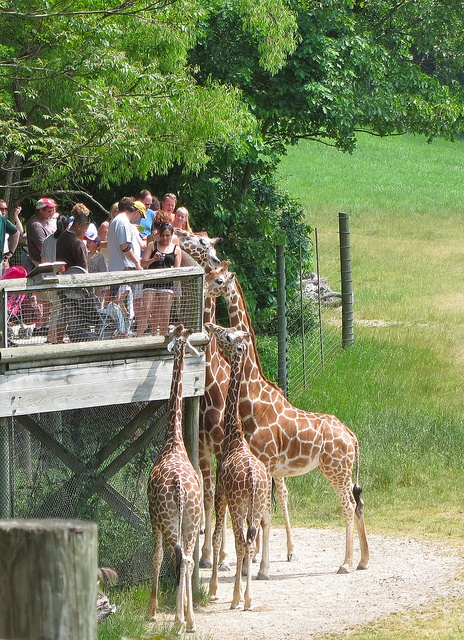Describe the objects in this image and their specific colors. I can see giraffe in olive, ivory, tan, and gray tones, giraffe in olive, gray, and lightgray tones, giraffe in olive, white, gray, maroon, and tan tones, giraffe in olive, maroon, lightgray, darkgray, and gray tones, and people in olive, gray, black, and darkgray tones in this image. 